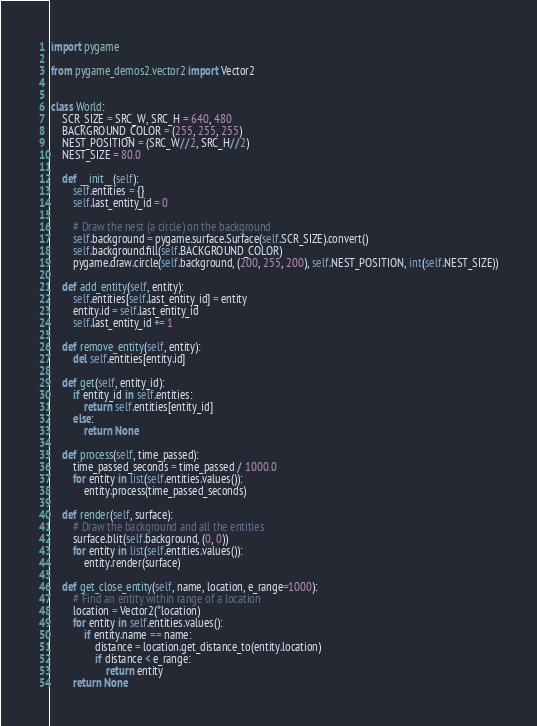<code> <loc_0><loc_0><loc_500><loc_500><_Python_>import pygame

from pygame_demos2.vector2 import Vector2


class World:
    SCR_SIZE = SRC_W, SRC_H = 640, 480
    BACKGROUND_COLOR = (255, 255, 255)
    NEST_POSITION = (SRC_W//2, SRC_H//2)
    NEST_SIZE = 80.0

    def __init__(self):
        self.entities = {}
        self.last_entity_id = 0

        # Draw the nest (a circle) on the background
        self.background = pygame.surface.Surface(self.SCR_SIZE).convert()
        self.background.fill(self.BACKGROUND_COLOR)
        pygame.draw.circle(self.background, (200, 255, 200), self.NEST_POSITION, int(self.NEST_SIZE))

    def add_entity(self, entity):
        self.entities[self.last_entity_id] = entity
        entity.id = self.last_entity_id
        self.last_entity_id += 1

    def remove_entity(self, entity):
        del self.entities[entity.id]

    def get(self, entity_id):
        if entity_id in self.entities:
            return self.entities[entity_id]
        else:
            return None

    def process(self, time_passed):
        time_passed_seconds = time_passed / 1000.0
        for entity in list(self.entities.values()):
            entity.process(time_passed_seconds)

    def render(self, surface):
        # Draw the background and all the entities
        surface.blit(self.background, (0, 0))
        for entity in list(self.entities.values()):
            entity.render(surface)

    def get_close_entity(self, name, location, e_range=1000):
        # Find an entity within range of a location
        location = Vector2(*location)
        for entity in self.entities.values():
            if entity.name == name:
                distance = location.get_distance_to(entity.location)
                if distance < e_range:
                    return entity
        return None
</code> 